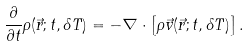Convert formula to latex. <formula><loc_0><loc_0><loc_500><loc_500>\frac { \partial } { \partial t } \rho ( \vec { r } ; t , \delta T ) = - \nabla \cdot \left [ \rho \vec { v } ( \vec { r } ; t , \delta T ) \right ] .</formula> 